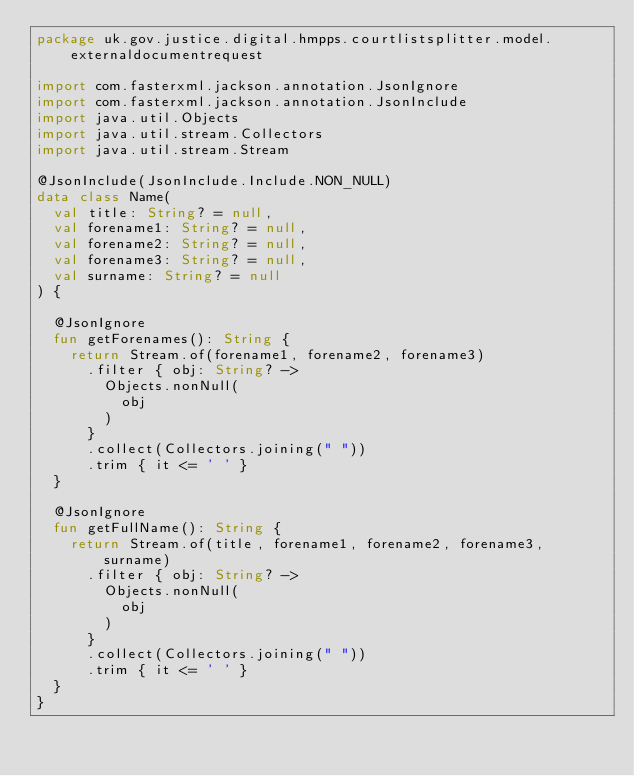<code> <loc_0><loc_0><loc_500><loc_500><_Kotlin_>package uk.gov.justice.digital.hmpps.courtlistsplitter.model.externaldocumentrequest

import com.fasterxml.jackson.annotation.JsonIgnore
import com.fasterxml.jackson.annotation.JsonInclude
import java.util.Objects
import java.util.stream.Collectors
import java.util.stream.Stream

@JsonInclude(JsonInclude.Include.NON_NULL)
data class Name(
  val title: String? = null,
  val forename1: String? = null,
  val forename2: String? = null,
  val forename3: String? = null,
  val surname: String? = null
) {

  @JsonIgnore
  fun getForenames(): String {
    return Stream.of(forename1, forename2, forename3)
      .filter { obj: String? ->
        Objects.nonNull(
          obj
        )
      }
      .collect(Collectors.joining(" "))
      .trim { it <= ' ' }
  }

  @JsonIgnore
  fun getFullName(): String {
    return Stream.of(title, forename1, forename2, forename3, surname)
      .filter { obj: String? ->
        Objects.nonNull(
          obj
        )
      }
      .collect(Collectors.joining(" "))
      .trim { it <= ' ' }
  }
}
</code> 